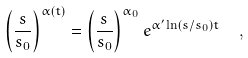Convert formula to latex. <formula><loc_0><loc_0><loc_500><loc_500>\left ( { \frac { s } { s _ { 0 } } } \right ) ^ { \alpha ( t ) } = \left ( { \frac { s } { s _ { 0 } } } \right ) ^ { \alpha _ { 0 } } e ^ { \alpha ^ { \prime } \ln \left ( s / s _ { 0 } \right ) t } \ \ ,</formula> 